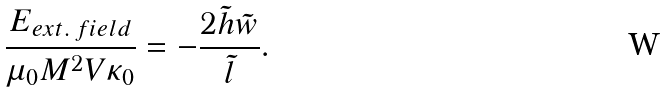<formula> <loc_0><loc_0><loc_500><loc_500>\frac { E _ { e x t . \, f i e l d } } { \mu _ { 0 } M ^ { 2 } V \kappa _ { 0 } } = - \frac { 2 \tilde { h } \tilde { w } } { \tilde { l } } .</formula> 